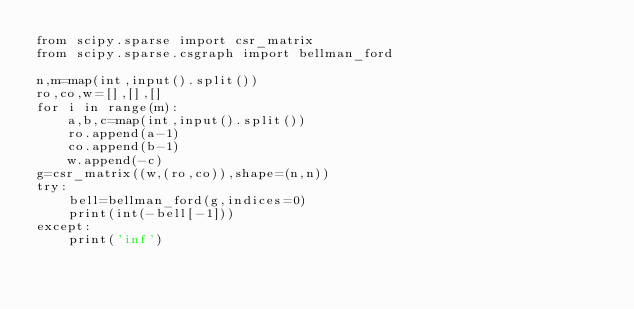Convert code to text. <code><loc_0><loc_0><loc_500><loc_500><_Python_>from scipy.sparse import csr_matrix
from scipy.sparse.csgraph import bellman_ford

n,m=map(int,input().split())
ro,co,w=[],[],[]
for i in range(m):
    a,b,c=map(int,input().split())
    ro.append(a-1)
    co.append(b-1)
    w.append(-c)
g=csr_matrix((w,(ro,co)),shape=(n,n))
try:
    bell=bellman_ford(g,indices=0)
    print(int(-bell[-1]))
except:
    print('inf')</code> 